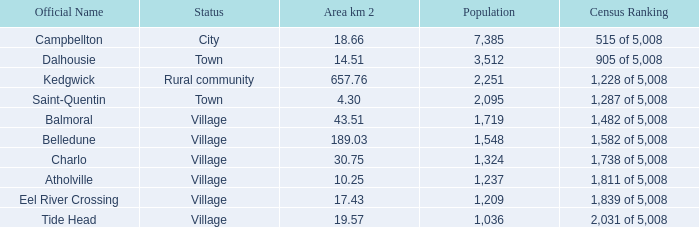For the balmoral community, covering an area of 43.51 square kilometers or more, what is the total number of inhabitants? 0.0. 